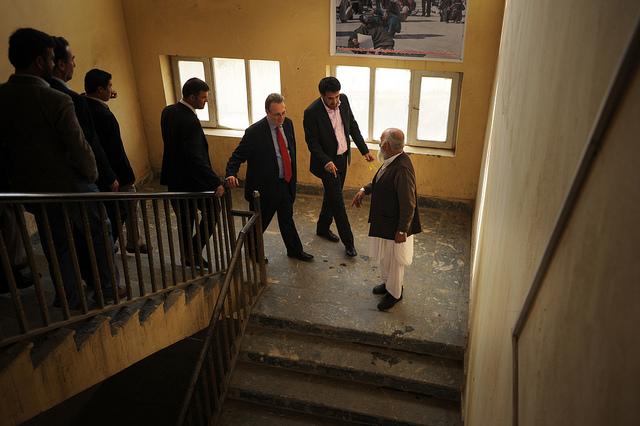Are these skiers?
Give a very brief answer. No. Are the stairs newly painted?
Answer briefly. No. How many people are wearing white trousers?
Be succinct. 1. How many pictures are in the background?
Be succinct. 1. How many people are in the photo?
Quick response, please. 7. What pattern in on the shirt behind the cat?
Keep it brief. Solid. What color are the boy's pants?
Be succinct. Black. Is everyone wearing a tie?
Answer briefly. No. 